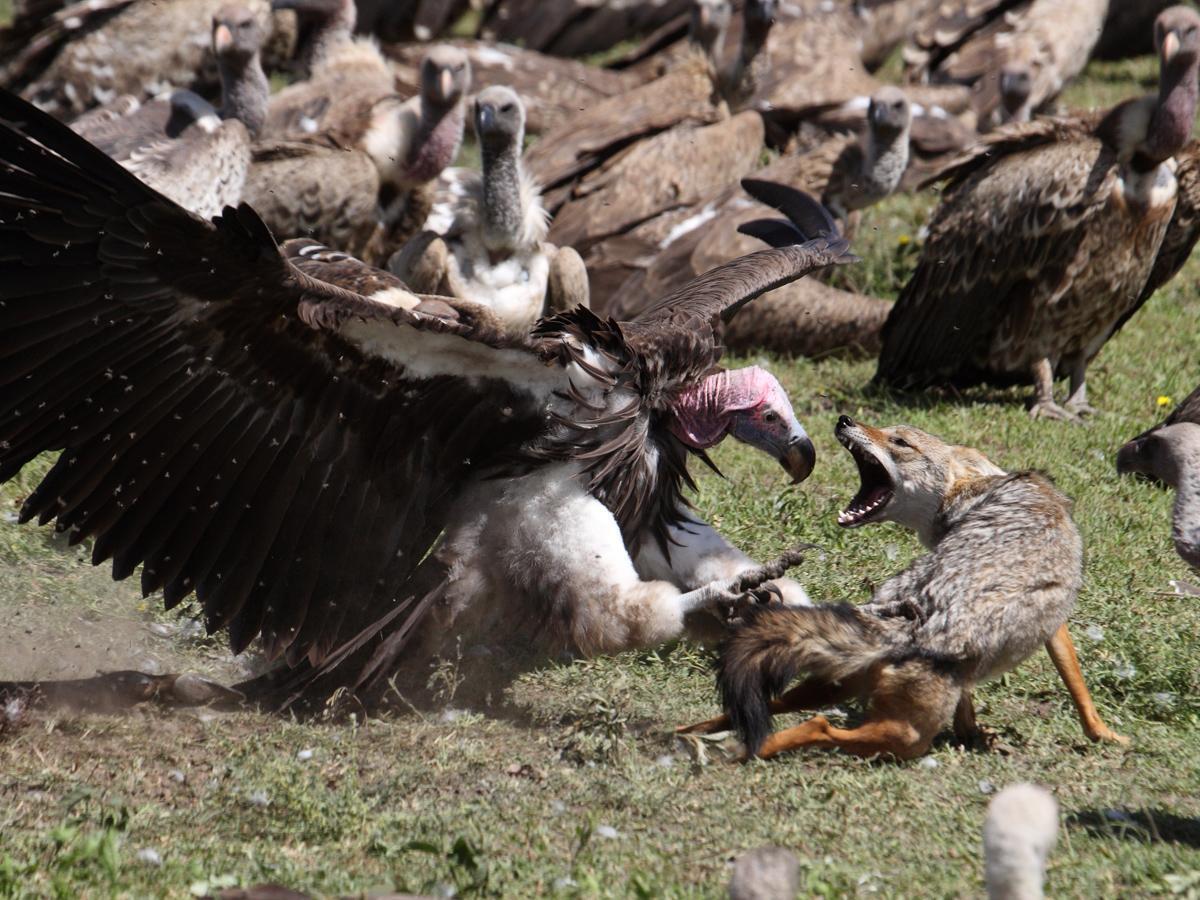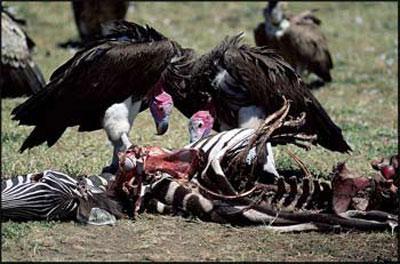The first image is the image on the left, the second image is the image on the right. For the images displayed, is the sentence "In one of the images, a lone bird is seen at the body of a dead animal." factually correct? Answer yes or no. No. The first image is the image on the left, the second image is the image on the right. For the images shown, is this caption "At least one of the images only has one bird standing on a dead animal." true? Answer yes or no. No. 